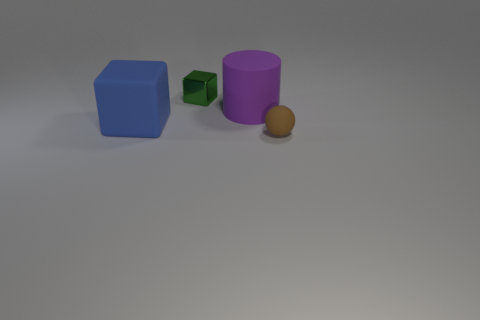Add 2 small yellow cylinders. How many objects exist? 6 Subtract all balls. How many objects are left? 3 Subtract all gray rubber balls. Subtract all big purple things. How many objects are left? 3 Add 1 metallic things. How many metallic things are left? 2 Add 3 blue shiny spheres. How many blue shiny spheres exist? 3 Subtract 0 red spheres. How many objects are left? 4 